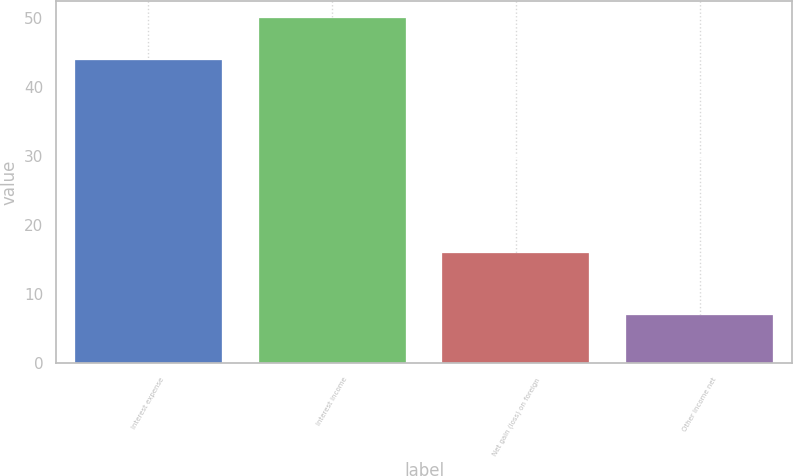<chart> <loc_0><loc_0><loc_500><loc_500><bar_chart><fcel>Interest expense<fcel>Interest income<fcel>Net gain (loss) on foreign<fcel>Other income net<nl><fcel>44<fcel>50<fcel>16<fcel>7<nl></chart> 